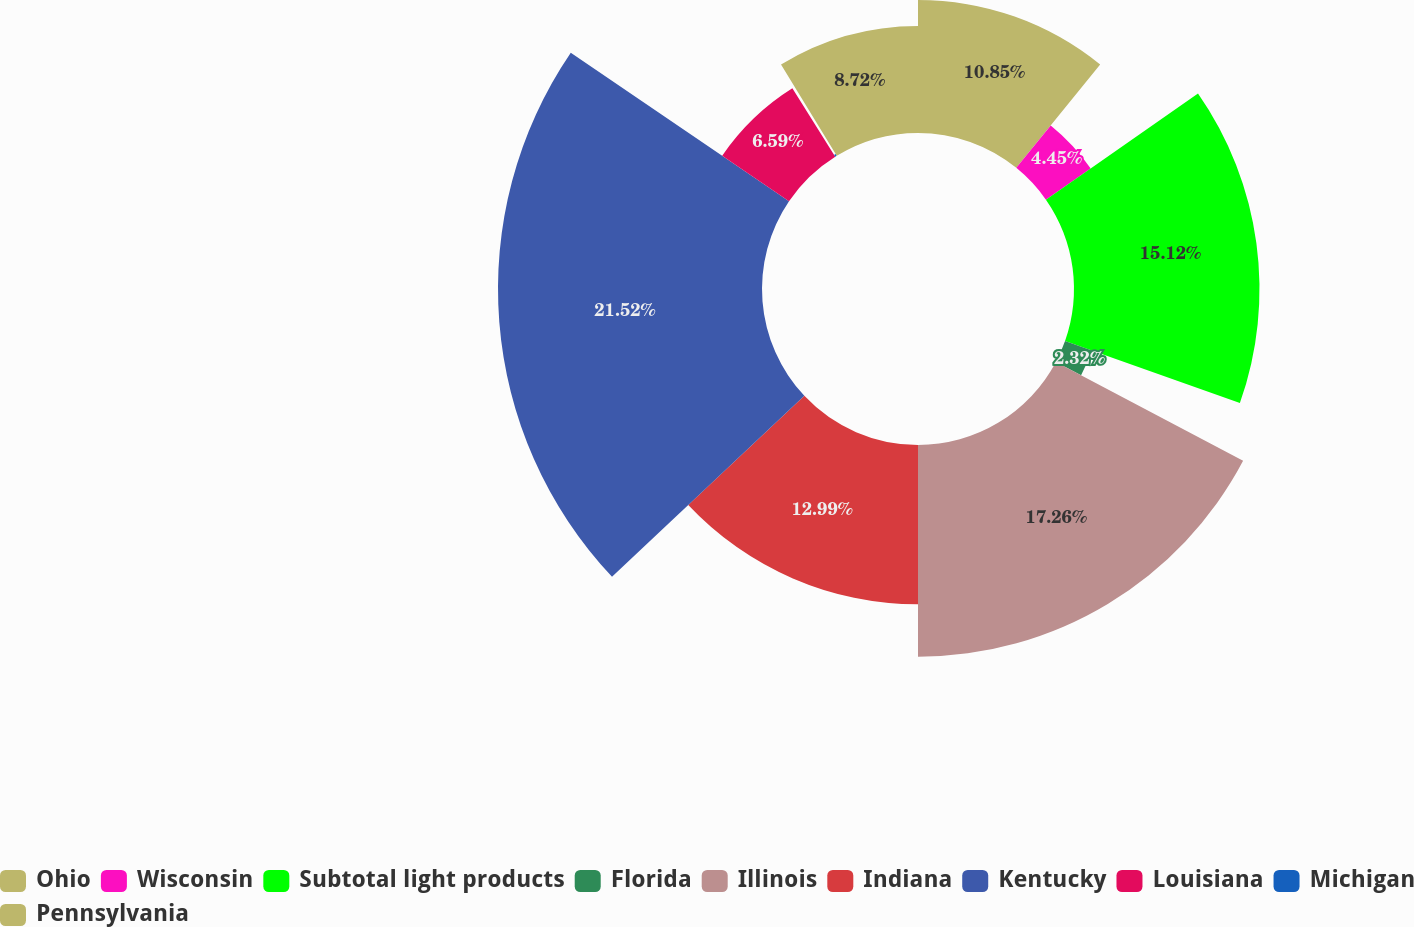Convert chart. <chart><loc_0><loc_0><loc_500><loc_500><pie_chart><fcel>Ohio<fcel>Wisconsin<fcel>Subtotal light products<fcel>Florida<fcel>Illinois<fcel>Indiana<fcel>Kentucky<fcel>Louisiana<fcel>Michigan<fcel>Pennsylvania<nl><fcel>10.85%<fcel>4.45%<fcel>15.12%<fcel>2.32%<fcel>17.26%<fcel>12.99%<fcel>21.52%<fcel>6.59%<fcel>0.18%<fcel>8.72%<nl></chart> 